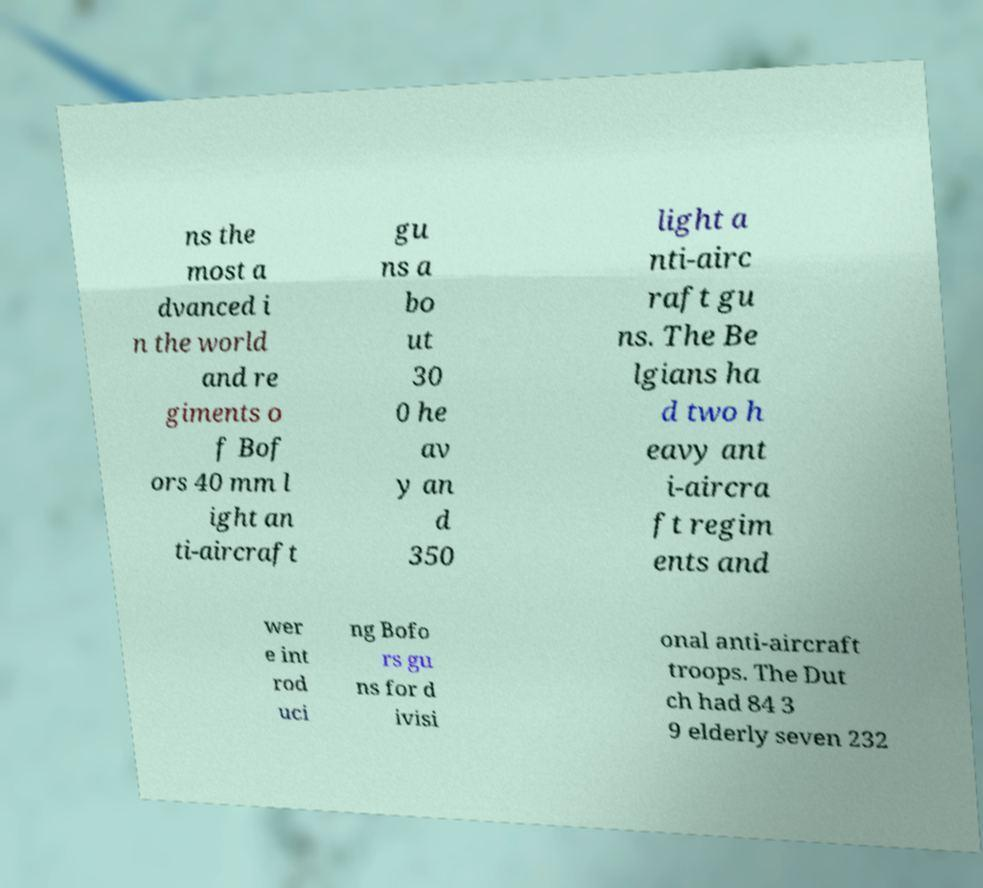I need the written content from this picture converted into text. Can you do that? ns the most a dvanced i n the world and re giments o f Bof ors 40 mm l ight an ti-aircraft gu ns a bo ut 30 0 he av y an d 350 light a nti-airc raft gu ns. The Be lgians ha d two h eavy ant i-aircra ft regim ents and wer e int rod uci ng Bofo rs gu ns for d ivisi onal anti-aircraft troops. The Dut ch had 84 3 9 elderly seven 232 